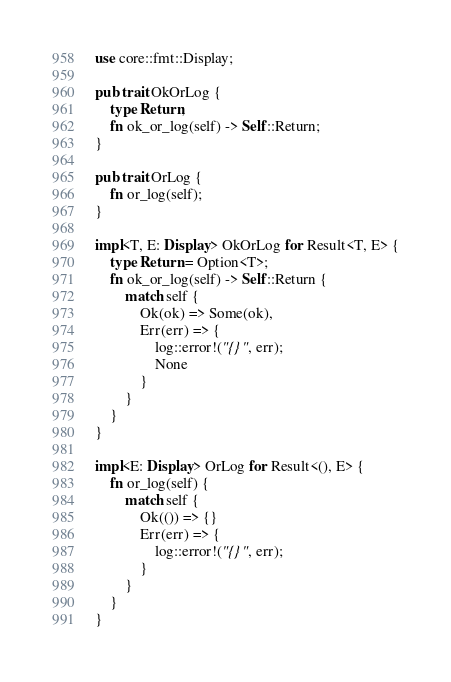<code> <loc_0><loc_0><loc_500><loc_500><_Rust_>use core::fmt::Display;

pub trait OkOrLog {
    type Return;
    fn ok_or_log(self) -> Self::Return;
}

pub trait OrLog {
    fn or_log(self);
}

impl<T, E: Display> OkOrLog for Result<T, E> {
    type Return = Option<T>;
    fn ok_or_log(self) -> Self::Return {
        match self {
            Ok(ok) => Some(ok),
            Err(err) => {
                log::error!("{}", err);
                None
            }
        }
    }
}

impl<E: Display> OrLog for Result<(), E> {
    fn or_log(self) {
        match self {
            Ok(()) => {}
            Err(err) => {
                log::error!("{}", err);
            }
        }
    }
}
</code> 